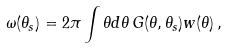Convert formula to latex. <formula><loc_0><loc_0><loc_500><loc_500>\omega ( \theta _ { s } ) = 2 \pi \int \theta d \theta \, G ( \theta , \theta _ { s } ) w ( \theta ) \, ,</formula> 